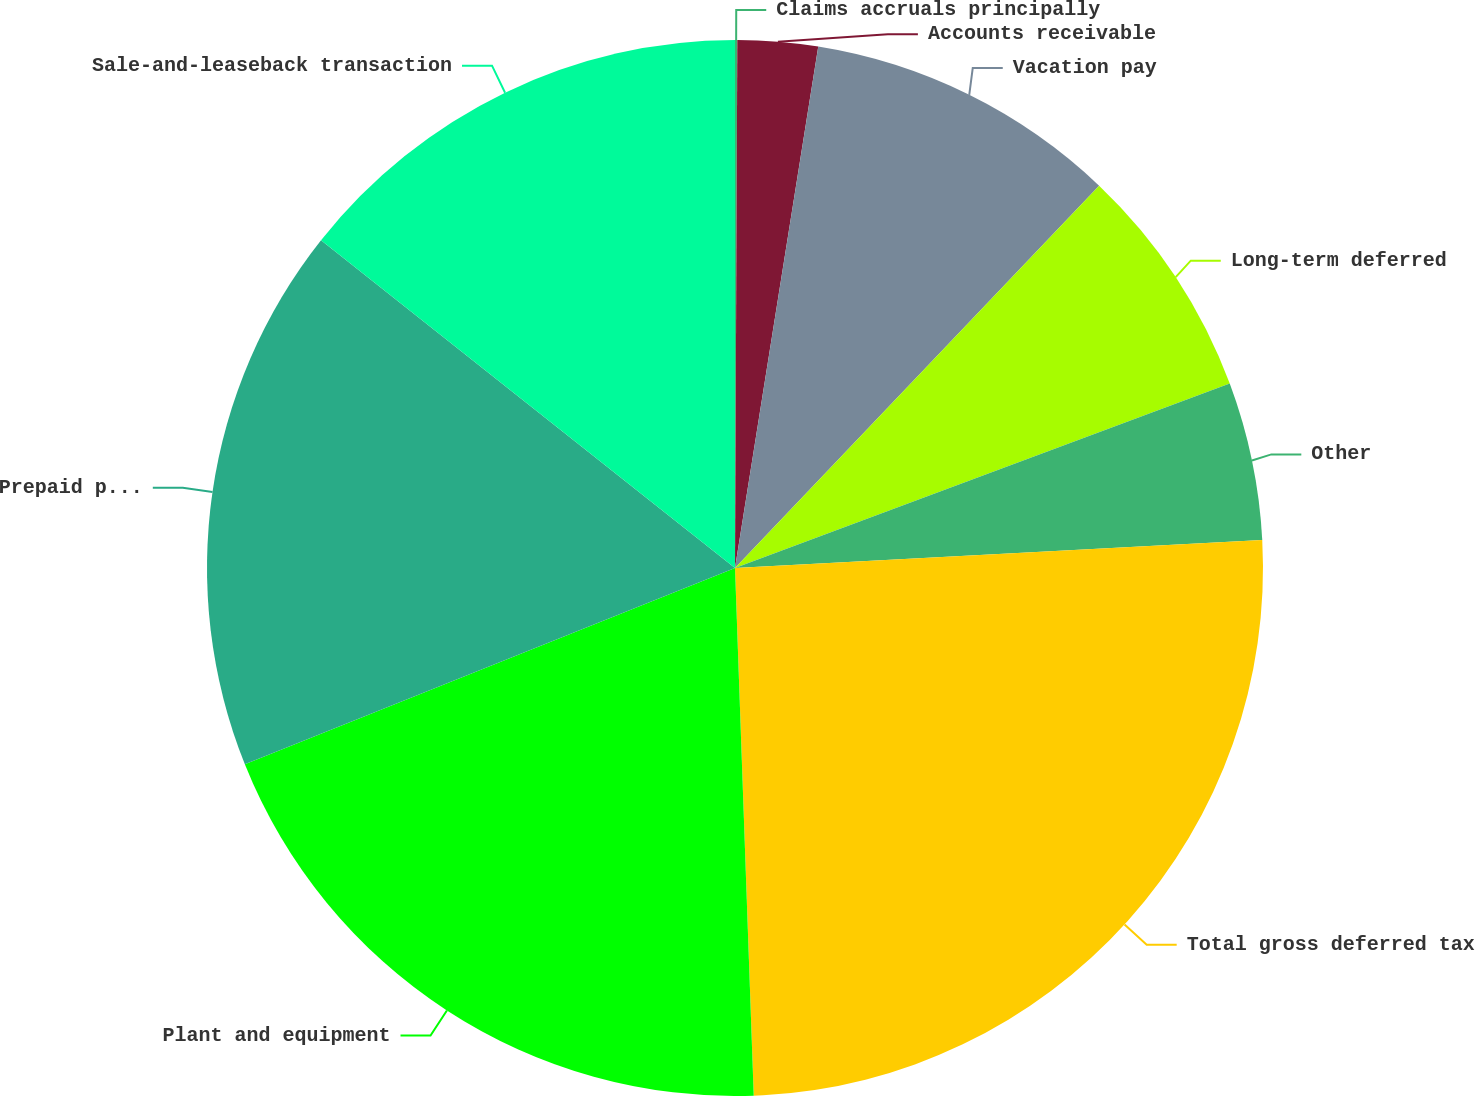<chart> <loc_0><loc_0><loc_500><loc_500><pie_chart><fcel>Claims accruals principally<fcel>Accounts receivable<fcel>Vacation pay<fcel>Long-term deferred<fcel>Other<fcel>Total gross deferred tax<fcel>Plant and equipment<fcel>Prepaid permits and insurance<fcel>Sale-and-leaseback transaction<nl><fcel>0.07%<fcel>2.45%<fcel>9.59%<fcel>7.21%<fcel>4.83%<fcel>25.28%<fcel>19.5%<fcel>16.72%<fcel>14.34%<nl></chart> 